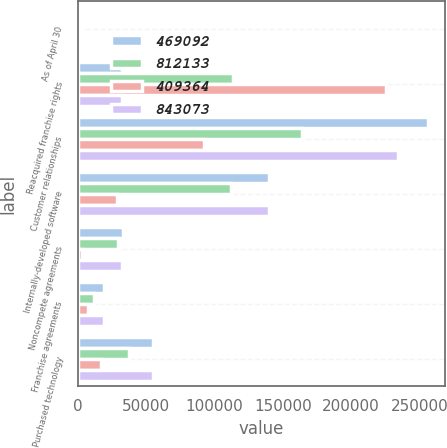Convert chart. <chart><loc_0><loc_0><loc_500><loc_500><stacked_bar_chart><ecel><fcel>As of April 30<fcel>Reacquired franchise rights<fcel>Customer relationships<fcel>Internally-developed software<fcel>Noncompete agreements<fcel>Franchise agreements<fcel>Purchased technology<nl><fcel>469092<fcel>2018<fcel>32653.5<fcel>256137<fcel>140255<fcel>32899<fcel>19201<fcel>54700<nl><fcel>812133<fcel>2018<fcel>113856<fcel>164005<fcel>111734<fcel>29673<fcel>12054<fcel>37770<nl><fcel>409364<fcel>2018<fcel>225923<fcel>92132<fcel>28521<fcel>3226<fcel>7147<fcel>16930<nl><fcel>843073<fcel>2017<fcel>32653.5<fcel>234603<fcel>139709<fcel>32408<fcel>19201<fcel>54700<nl></chart> 